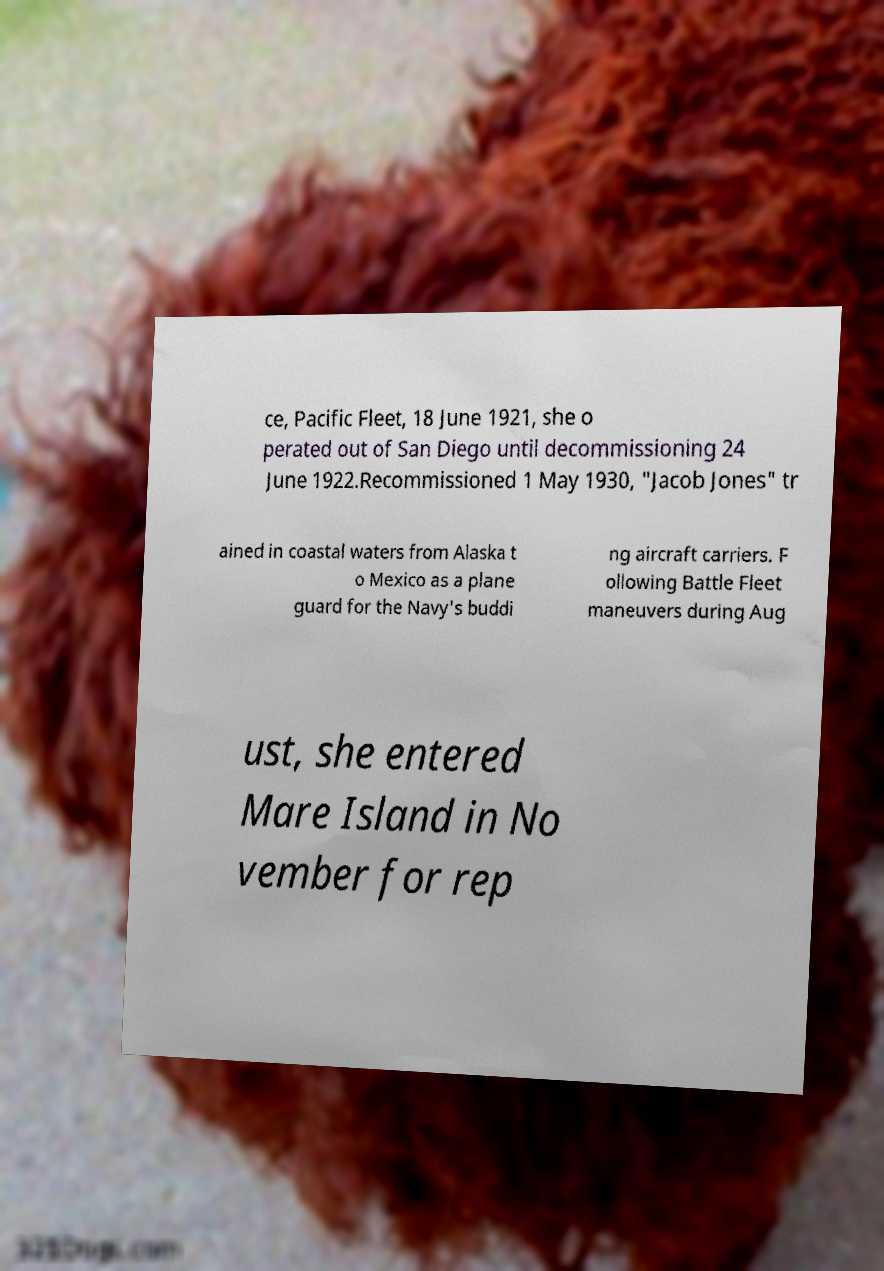Can you accurately transcribe the text from the provided image for me? ce, Pacific Fleet, 18 June 1921, she o perated out of San Diego until decommissioning 24 June 1922.Recommissioned 1 May 1930, "Jacob Jones" tr ained in coastal waters from Alaska t o Mexico as a plane guard for the Navy's buddi ng aircraft carriers. F ollowing Battle Fleet maneuvers during Aug ust, she entered Mare Island in No vember for rep 